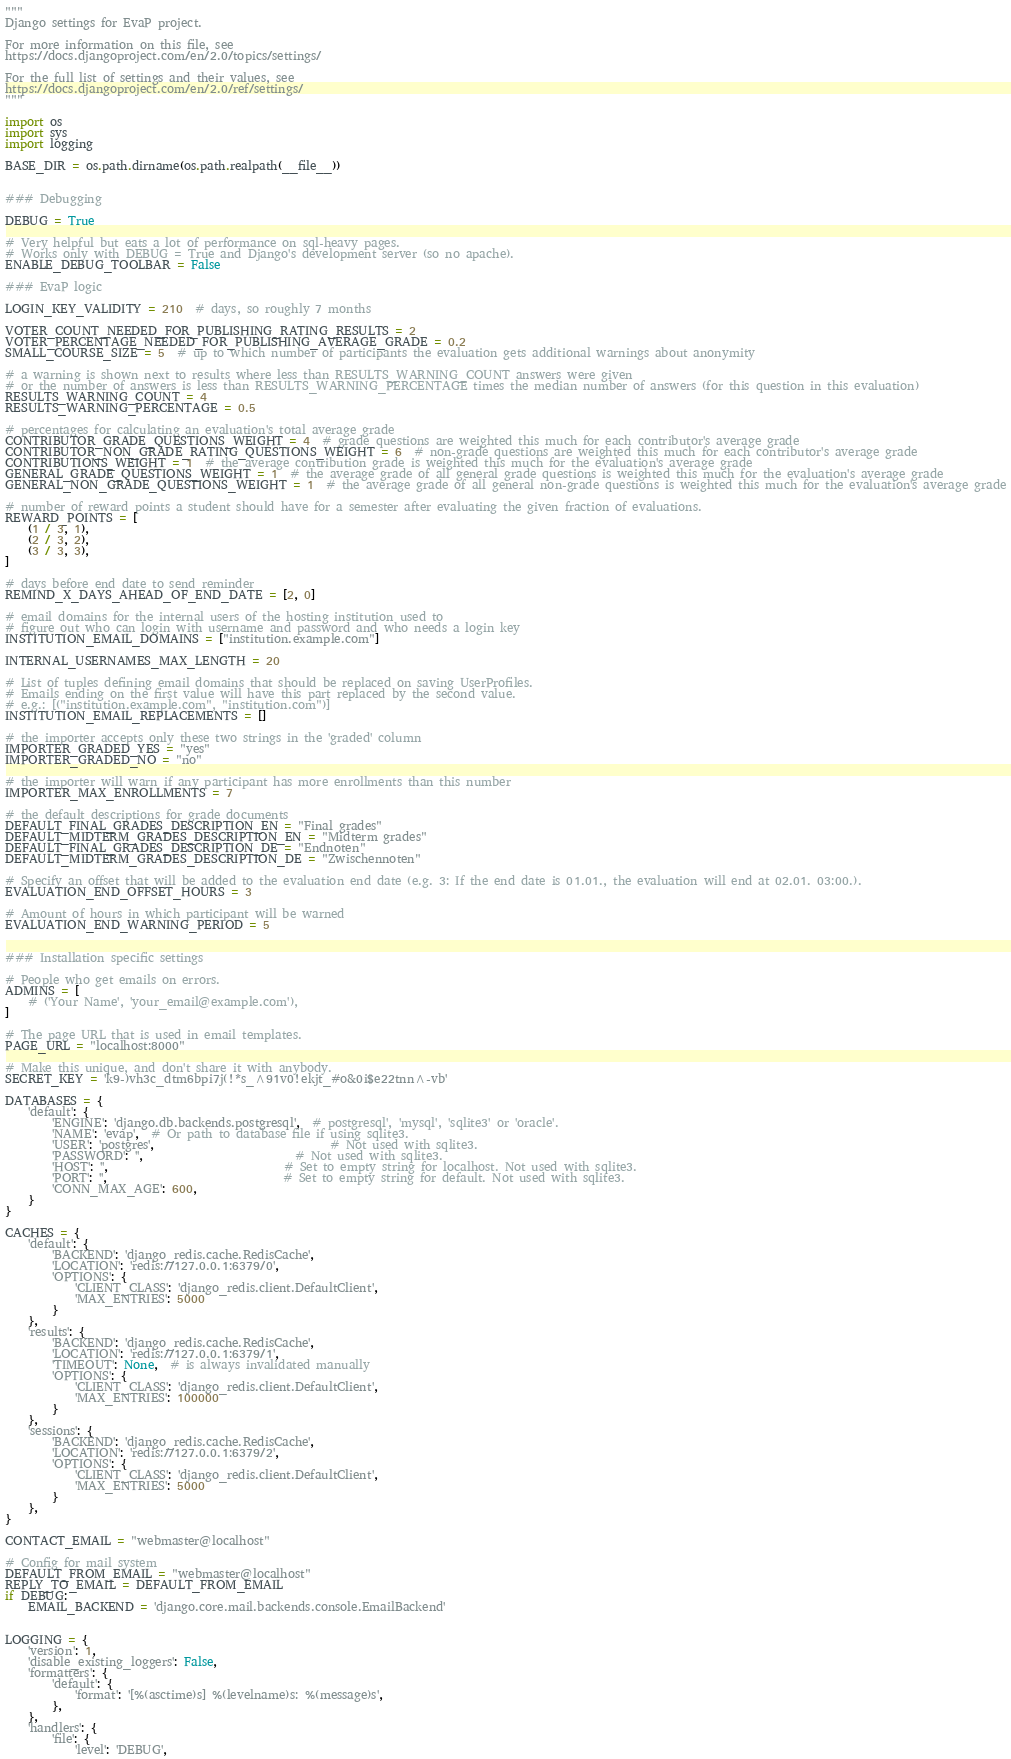<code> <loc_0><loc_0><loc_500><loc_500><_Python_>"""
Django settings for EvaP project.

For more information on this file, see
https://docs.djangoproject.com/en/2.0/topics/settings/

For the full list of settings and their values, see
https://docs.djangoproject.com/en/2.0/ref/settings/
"""

import os
import sys
import logging

BASE_DIR = os.path.dirname(os.path.realpath(__file__))


### Debugging

DEBUG = True

# Very helpful but eats a lot of performance on sql-heavy pages.
# Works only with DEBUG = True and Django's development server (so no apache).
ENABLE_DEBUG_TOOLBAR = False

### EvaP logic

LOGIN_KEY_VALIDITY = 210  # days, so roughly 7 months

VOTER_COUNT_NEEDED_FOR_PUBLISHING_RATING_RESULTS = 2
VOTER_PERCENTAGE_NEEDED_FOR_PUBLISHING_AVERAGE_GRADE = 0.2
SMALL_COURSE_SIZE = 5  # up to which number of participants the evaluation gets additional warnings about anonymity

# a warning is shown next to results where less than RESULTS_WARNING_COUNT answers were given
# or the number of answers is less than RESULTS_WARNING_PERCENTAGE times the median number of answers (for this question in this evaluation)
RESULTS_WARNING_COUNT = 4
RESULTS_WARNING_PERCENTAGE = 0.5

# percentages for calculating an evaluation's total average grade
CONTRIBUTOR_GRADE_QUESTIONS_WEIGHT = 4  # grade questions are weighted this much for each contributor's average grade
CONTRIBUTOR_NON_GRADE_RATING_QUESTIONS_WEIGHT = 6  # non-grade questions are weighted this much for each contributor's average grade
CONTRIBUTIONS_WEIGHT = 1  # the average contribution grade is weighted this much for the evaluation's average grade
GENERAL_GRADE_QUESTIONS_WEIGHT = 1  # the average grade of all general grade questions is weighted this much for the evaluation's average grade
GENERAL_NON_GRADE_QUESTIONS_WEIGHT = 1  # the average grade of all general non-grade questions is weighted this much for the evaluation's average grade

# number of reward points a student should have for a semester after evaluating the given fraction of evaluations.
REWARD_POINTS = [
    (1 / 3, 1),
    (2 / 3, 2),
    (3 / 3, 3),
]

# days before end date to send reminder
REMIND_X_DAYS_AHEAD_OF_END_DATE = [2, 0]

# email domains for the internal users of the hosting institution used to
# figure out who can login with username and password and who needs a login key
INSTITUTION_EMAIL_DOMAINS = ["institution.example.com"]

INTERNAL_USERNAMES_MAX_LENGTH = 20

# List of tuples defining email domains that should be replaced on saving UserProfiles.
# Emails ending on the first value will have this part replaced by the second value.
# e.g.: [("institution.example.com", "institution.com")]
INSTITUTION_EMAIL_REPLACEMENTS = []

# the importer accepts only these two strings in the 'graded' column
IMPORTER_GRADED_YES = "yes"
IMPORTER_GRADED_NO = "no"

# the importer will warn if any participant has more enrollments than this number
IMPORTER_MAX_ENROLLMENTS = 7

# the default descriptions for grade documents
DEFAULT_FINAL_GRADES_DESCRIPTION_EN = "Final grades"
DEFAULT_MIDTERM_GRADES_DESCRIPTION_EN = "Midterm grades"
DEFAULT_FINAL_GRADES_DESCRIPTION_DE = "Endnoten"
DEFAULT_MIDTERM_GRADES_DESCRIPTION_DE = "Zwischennoten"

# Specify an offset that will be added to the evaluation end date (e.g. 3: If the end date is 01.01., the evaluation will end at 02.01. 03:00.).
EVALUATION_END_OFFSET_HOURS = 3

# Amount of hours in which participant will be warned
EVALUATION_END_WARNING_PERIOD = 5


### Installation specific settings

# People who get emails on errors.
ADMINS = [
    # ('Your Name', 'your_email@example.com'),
]

# The page URL that is used in email templates.
PAGE_URL = "localhost:8000"

# Make this unique, and don't share it with anybody.
SECRET_KEY = 'k9-)vh3c_dtm6bpi7j(!*s_^91v0!ekjt_#o&0i$e22tnn^-vb'

DATABASES = {
    'default': {
        'ENGINE': 'django.db.backends.postgresql',  # postgresql', 'mysql', 'sqlite3' or 'oracle'.
        'NAME': 'evap',  # Or path to database file if using sqlite3.
        'USER': 'postgres',                              # Not used with sqlite3.
        'PASSWORD': '',                          # Not used with sqlite3.
        'HOST': '',                              # Set to empty string for localhost. Not used with sqlite3.
        'PORT': '',                              # Set to empty string for default. Not used with sqlite3.
        'CONN_MAX_AGE': 600,
    }
}

CACHES = {
    'default': {
        'BACKEND': 'django_redis.cache.RedisCache',
        'LOCATION': 'redis://127.0.0.1:6379/0',
        'OPTIONS': {
            'CLIENT_CLASS': 'django_redis.client.DefaultClient',
            'MAX_ENTRIES': 5000
        }
    },
    'results': {
        'BACKEND': 'django_redis.cache.RedisCache',
        'LOCATION': 'redis://127.0.0.1:6379/1',
        'TIMEOUT': None,  # is always invalidated manually
        'OPTIONS': {
            'CLIENT_CLASS': 'django_redis.client.DefaultClient',
            'MAX_ENTRIES': 100000
        }
    },
    'sessions': {
        'BACKEND': 'django_redis.cache.RedisCache',
        'LOCATION': 'redis://127.0.0.1:6379/2',
        'OPTIONS': {
            'CLIENT_CLASS': 'django_redis.client.DefaultClient',
            'MAX_ENTRIES': 5000
        }
    },
}

CONTACT_EMAIL = "webmaster@localhost"

# Config for mail system
DEFAULT_FROM_EMAIL = "webmaster@localhost"
REPLY_TO_EMAIL = DEFAULT_FROM_EMAIL
if DEBUG:
    EMAIL_BACKEND = 'django.core.mail.backends.console.EmailBackend'


LOGGING = {
    'version': 1,
    'disable_existing_loggers': False,
    'formatters': {
        'default': {
            'format': '[%(asctime)s] %(levelname)s: %(message)s',
        },
    },
    'handlers': {
        'file': {
            'level': 'DEBUG',</code> 